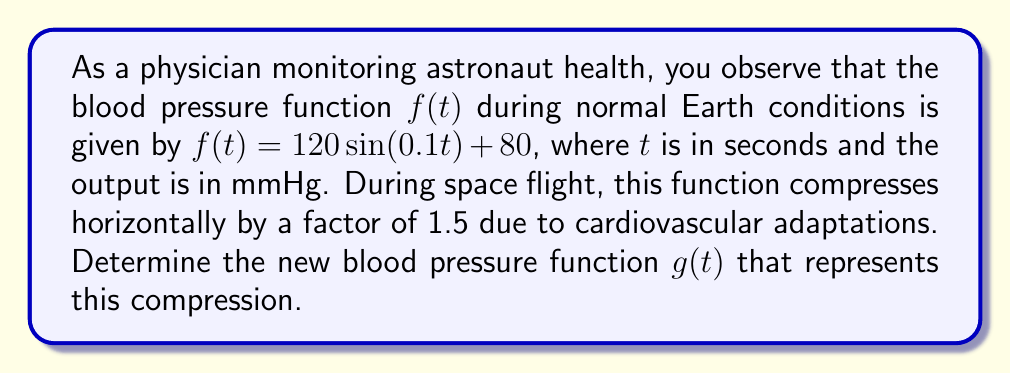Can you solve this math problem? To solve this problem, we need to apply a horizontal compression to the given function. Here's the step-by-step process:

1) The original function is $f(t) = 120 \sin(0.1t) + 80$.

2) A horizontal compression by a factor of $k$ is achieved by replacing $t$ with $kt$ in the original function. In this case, $k = 1.5$.

3) We replace $t$ with $1.5t$ in the original function:

   $g(t) = 120 \sin(0.1(1.5t)) + 80$

4) Simplify the argument of the sine function:

   $g(t) = 120 \sin(0.15t) + 80$

This new function $g(t)$ represents the compressed blood pressure function during space flight. The period of the sine wave has decreased, reflecting the faster oscillation of blood pressure in microgravity conditions.
Answer: $g(t) = 120 \sin(0.15t) + 80$ 